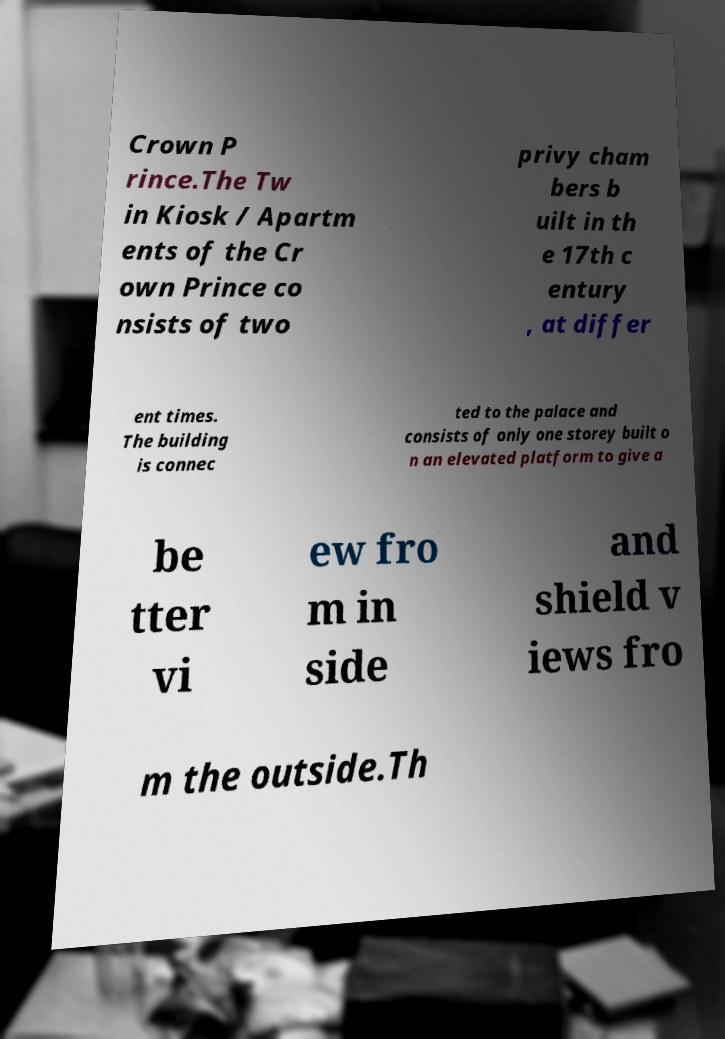For documentation purposes, I need the text within this image transcribed. Could you provide that? Crown P rince.The Tw in Kiosk / Apartm ents of the Cr own Prince co nsists of two privy cham bers b uilt in th e 17th c entury , at differ ent times. The building is connec ted to the palace and consists of only one storey built o n an elevated platform to give a be tter vi ew fro m in side and shield v iews fro m the outside.Th 